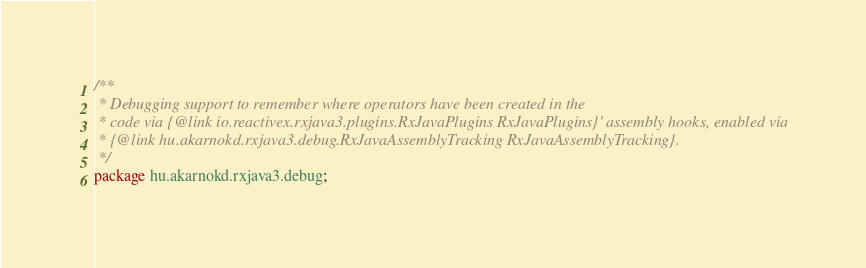<code> <loc_0><loc_0><loc_500><loc_500><_Java_>/**
 * Debugging support to remember where operators have been created in the
 * code via {@link io.reactivex.rxjava3.plugins.RxJavaPlugins RxJavaPlugins}' assembly hooks, enabled via
 * {@link hu.akarnokd.rxjava3.debug.RxJavaAssemblyTracking RxJavaAssemblyTracking}.
 */
package hu.akarnokd.rxjava3.debug;</code> 